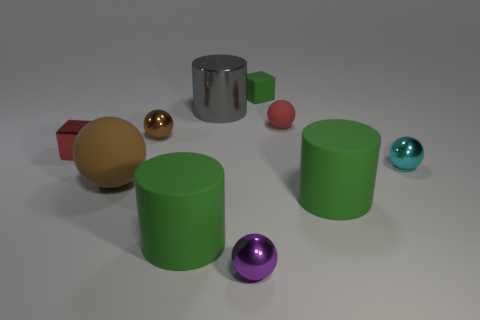There is a big matte thing that is the same shape as the cyan shiny object; what is its color?
Ensure brevity in your answer.  Brown. Is there anything else of the same color as the big shiny cylinder?
Make the answer very short. No. There is a small thing left of the brown ball to the left of the brown object that is behind the cyan sphere; what shape is it?
Make the answer very short. Cube. There is a matte ball in front of the cyan metallic ball; is it the same size as the green rubber thing that is left of the small rubber block?
Your answer should be very brief. Yes. How many purple balls have the same material as the cyan sphere?
Your answer should be very brief. 1. What number of small blocks are on the left side of the matte object that is to the left of the green rubber cylinder that is to the left of the big metal thing?
Your response must be concise. 1. Does the cyan metallic object have the same shape as the large gray metallic object?
Your answer should be compact. No. Are there any red metal objects of the same shape as the tiny green matte thing?
Provide a short and direct response. Yes. There is a green matte object that is the same size as the purple ball; what shape is it?
Provide a short and direct response. Cube. What is the material of the small red thing left of the tiny cube that is to the right of the small red thing that is on the left side of the tiny brown metallic thing?
Your response must be concise. Metal. 